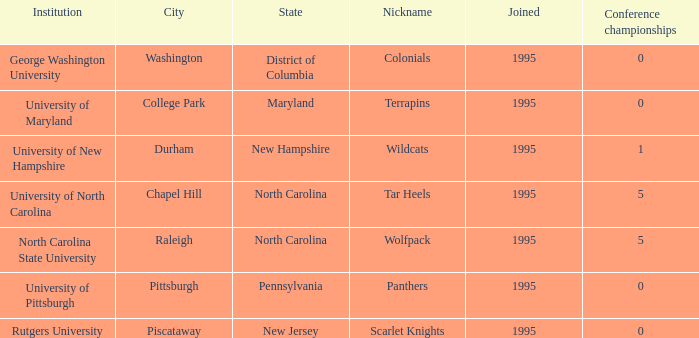What is the latest year joined with a Conference championships of 5, and an Institution of university of north carolina? 1995.0. 